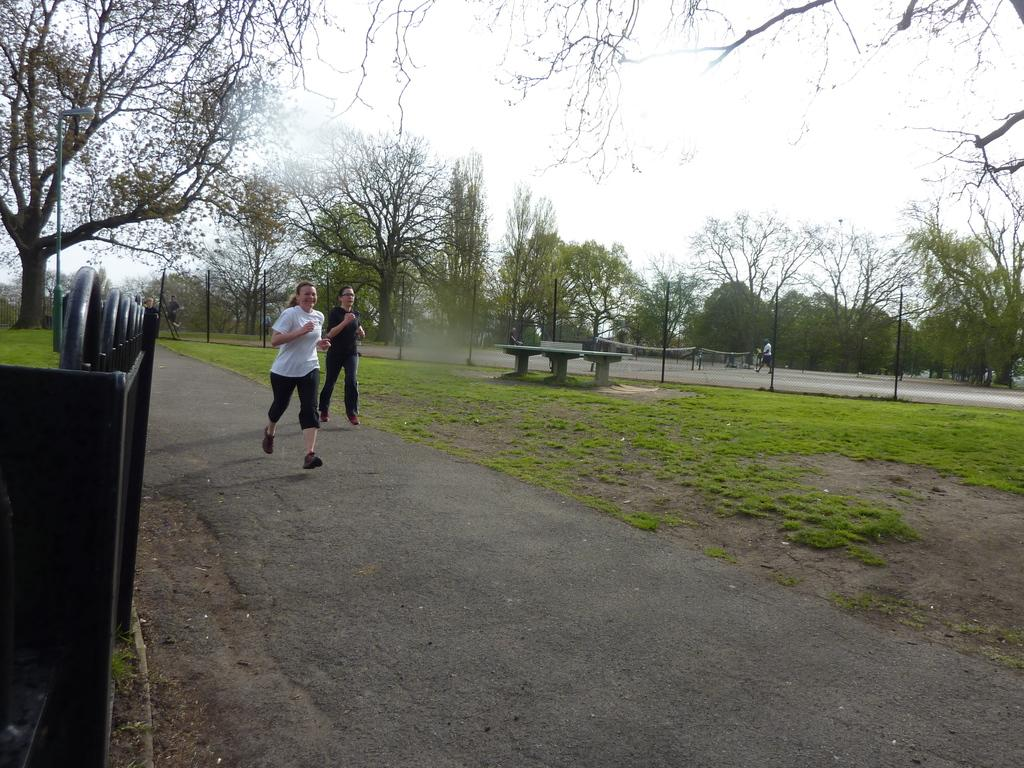What are the two ladies in the image doing? The two ladies are running in the image. Where are the ladies running? The ladies are running on a road. What can be seen on the left side of the image? There is a metal structure on the left side of the image. What is visible in the background of the image? There are trees and the sky visible in the background of the image. What type of coach can be seen in the image? There is no coach present in the image. What is the taste of the trees in the background of the image? Trees do not have a taste, and there is no mention of any taste in the image. 